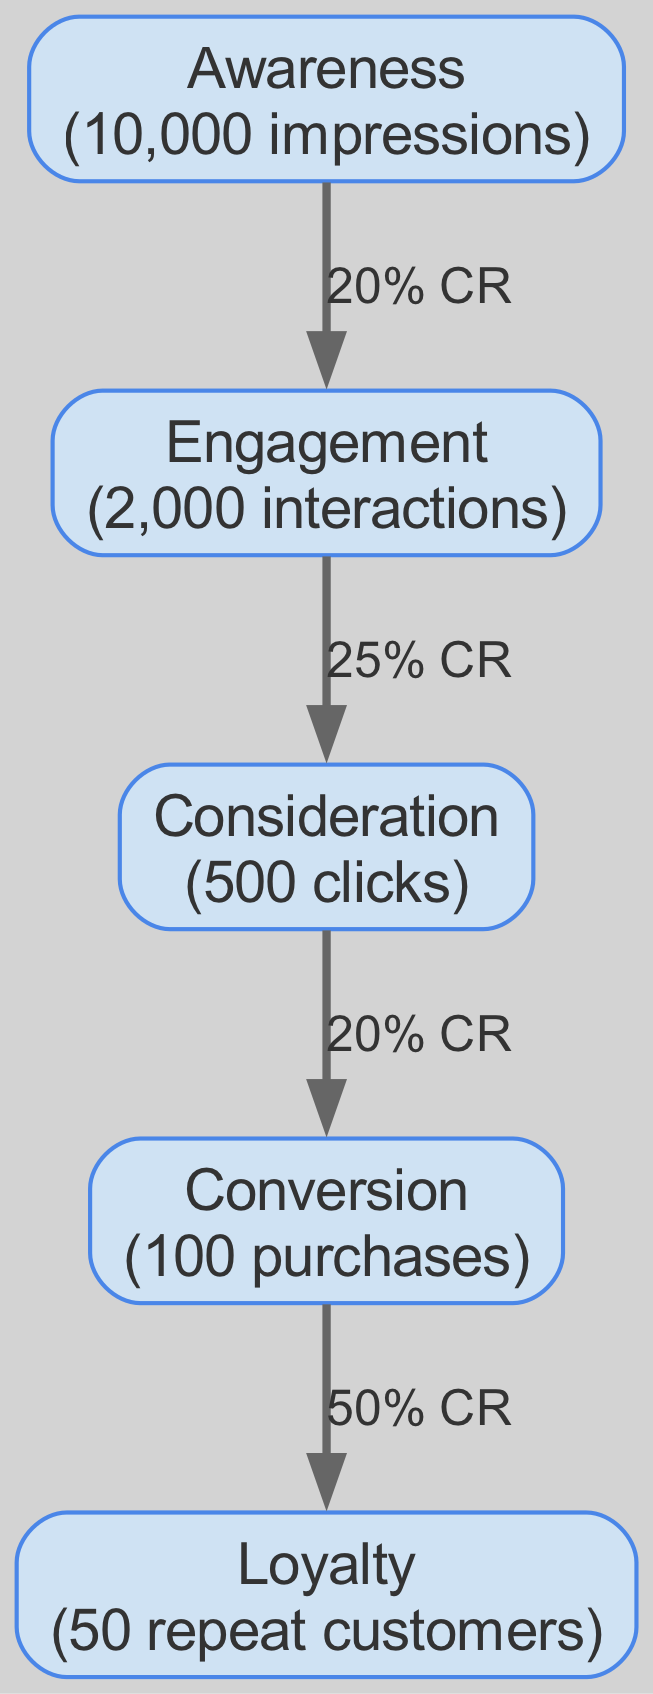What is the total number of nodes in the diagram? The diagram contains five unique stages, which are Awareness, Engagement, Consideration, Conversion, and Loyalty. By counting these, we find that there are a total of five nodes.
Answer: 5 What is the conversion rate from Engagement to Consideration? The edge connecting Engagement to Consideration specifies a conversion rate of 25%. Therefore, the conversion rate between these two nodes is 25%.
Answer: 25% How many interactions are there in the Engagement stage? The Engagement node shows "2,000 interactions" as its label. Therefore, there are 2,000 interactions in total at this stage.
Answer: 2000 What is the relationship between Conversion and Loyalty? The edge from the Conversion node to the Loyalty node indicates a 50% conversion rate, which represents the connection and flow from Conversion to Loyalty.
Answer: 50% CR What is the total number of purchases made in the Conversion stage? The Conversion node displays "100 purchases." This indicates that there were 100 purchases made at this stage of the funnel.
Answer: 100 What is the conversion rate from Awareness to Engagement? The edge leading from Awareness to Engagement shows a conversion rate of 20%. Therefore, the conversion rate from Awareness to Engagement is 20%.
Answer: 20% Which stage has the highest drop-off in terms of conversion? By examining the stages and their respective conversion rates, the drop-off from Engagement to Consideration is significant, as it shows a decrease from 2,000 interactions to 500 clicks, indicating a large drop-off in conversions.
Answer: Engagement to Consideration What percentage of Awareness leads to Loyalty? To find the percentage of Awareness leading to Loyalty, we take the number of repeat customers at the Loyalty stage (50) and relate it to the total impressions from the Awareness stage (10,000). This means 50 out of 10,000 leads to 0.5%.
Answer: 0.5% 